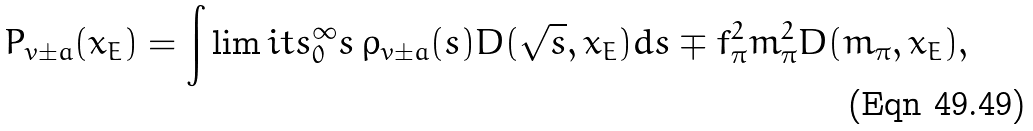<formula> <loc_0><loc_0><loc_500><loc_500>P _ { v \pm a } ( x _ { E } ) = \int \lim i t s _ { 0 } ^ { \infty } s \, \rho _ { v \pm a } ( s ) D ( \sqrt { s } , x _ { E } ) d s \mp f _ { \pi } ^ { 2 } m _ { \pi } ^ { 2 } D ( m _ { \pi } , x _ { E } ) ,</formula> 